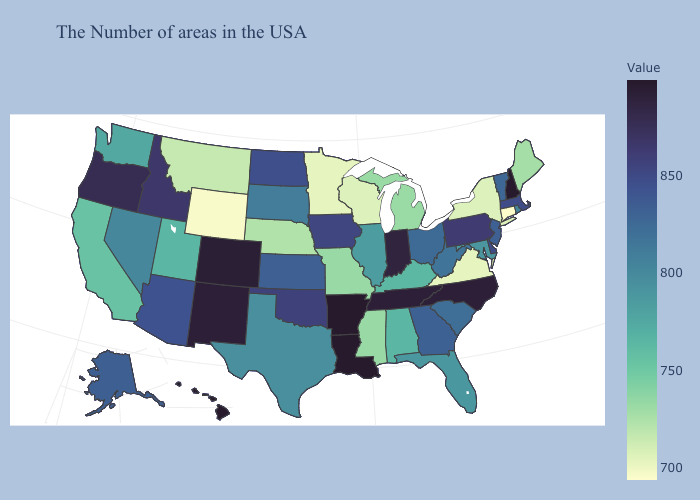Does South Dakota have a higher value than Nebraska?
Give a very brief answer. Yes. Does New Hampshire have the highest value in the USA?
Be succinct. Yes. Which states have the highest value in the USA?
Keep it brief. New Hampshire, Louisiana, Arkansas. Among the states that border Texas , which have the lowest value?
Be succinct. Oklahoma. Among the states that border Indiana , which have the lowest value?
Be succinct. Michigan. Among the states that border Kentucky , does Tennessee have the highest value?
Write a very short answer. Yes. 